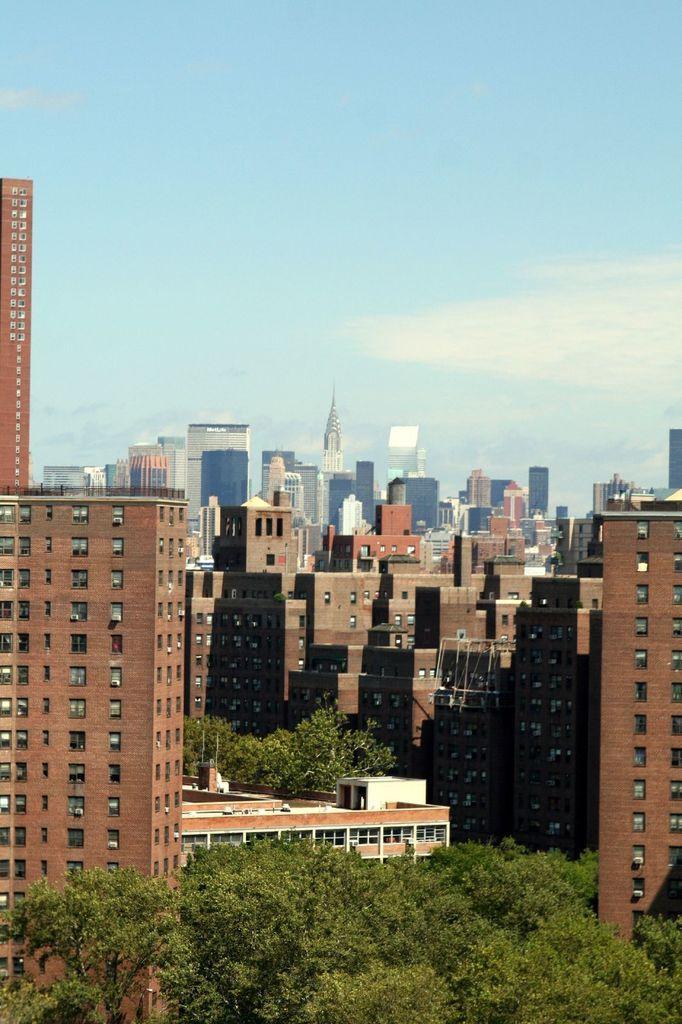In one or two sentences, can you explain what this image depicts? In this image we can see the buildings. In front of the building there are trees and sky in the background. 